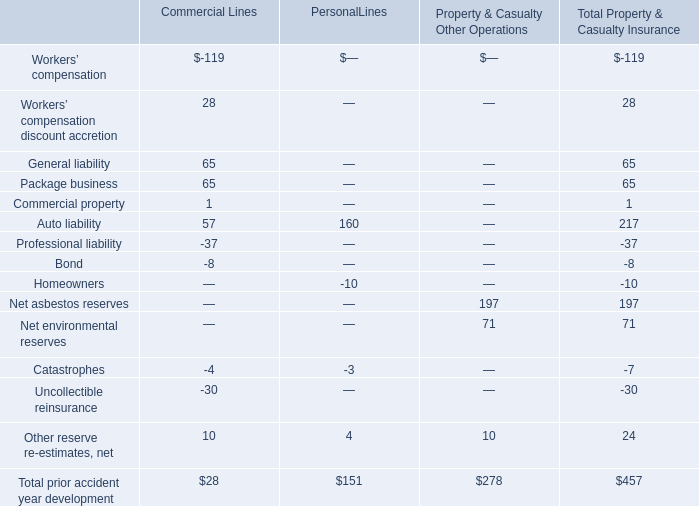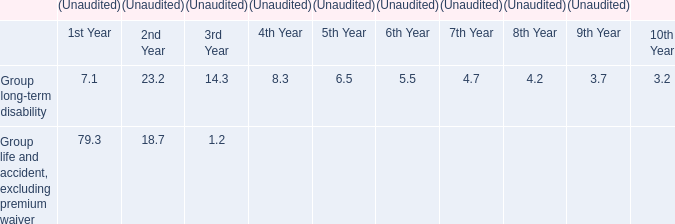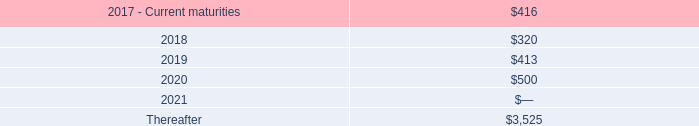What is the sum of Bond, Homeowners and Net asbestos reserves for Total Property & Casualty Insurance ? 
Computations: ((-8 - 10) + 197)
Answer: 179.0. 